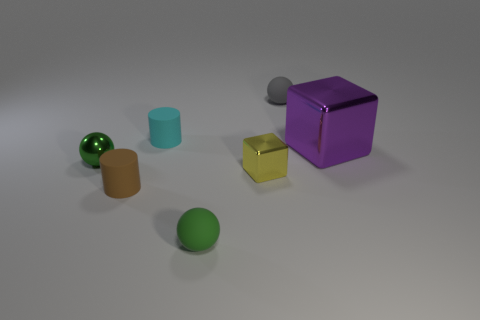Add 1 cyan cylinders. How many objects exist? 8 Subtract all cylinders. How many objects are left? 5 Subtract all tiny blue cubes. Subtract all small cylinders. How many objects are left? 5 Add 5 gray balls. How many gray balls are left? 6 Add 3 green rubber cubes. How many green rubber cubes exist? 3 Subtract 1 cyan cylinders. How many objects are left? 6 